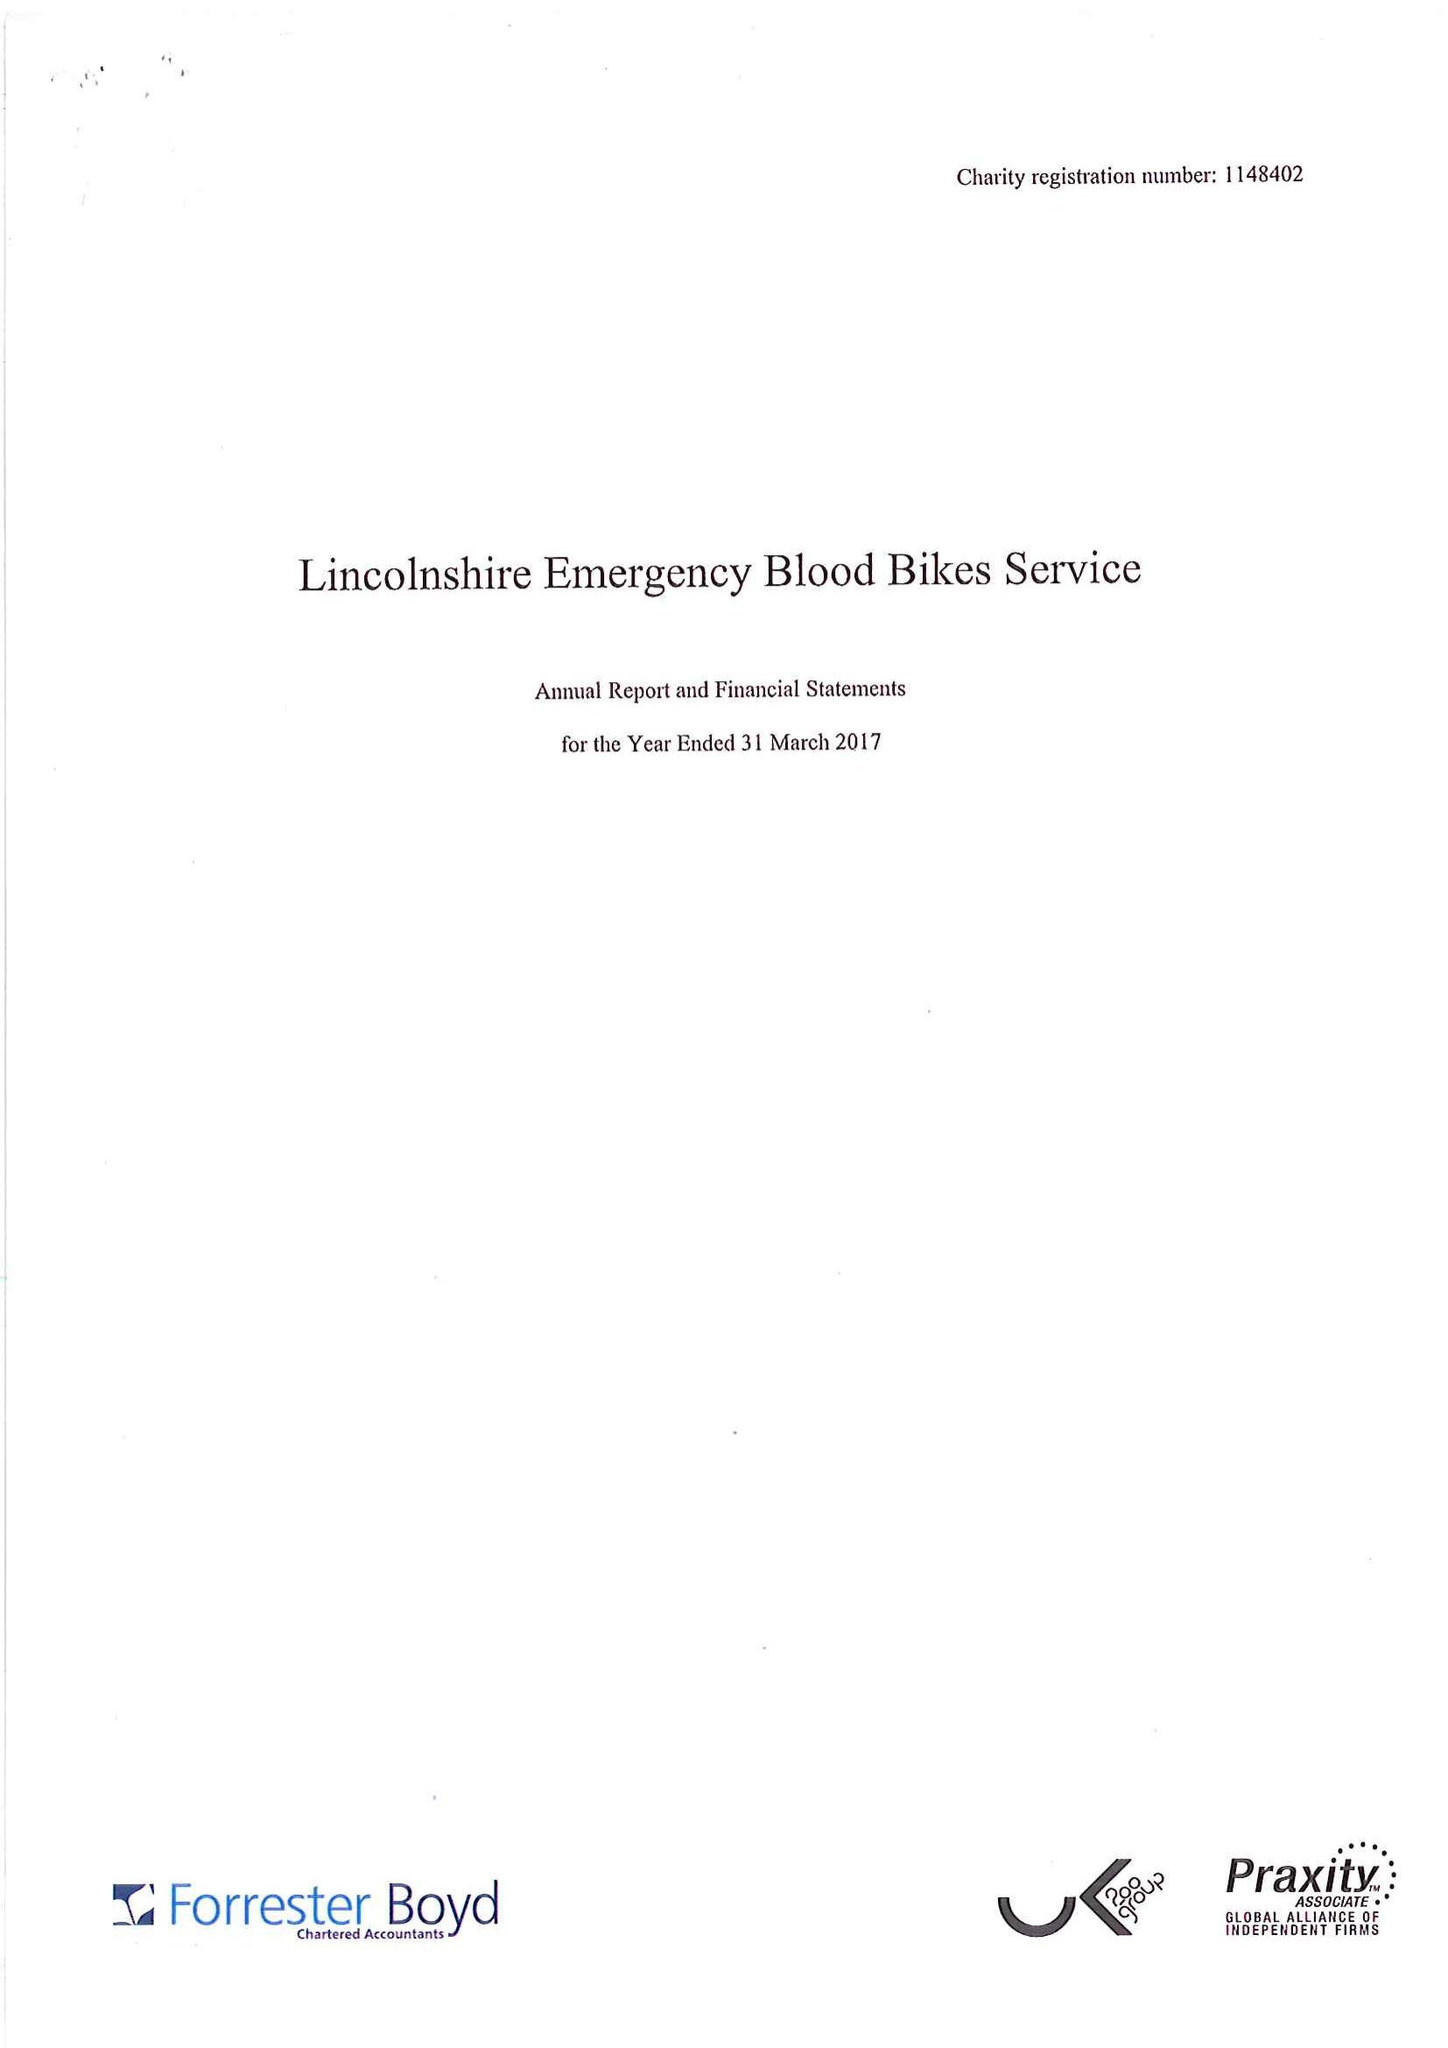What is the value for the income_annually_in_british_pounds?
Answer the question using a single word or phrase. 36724.00 